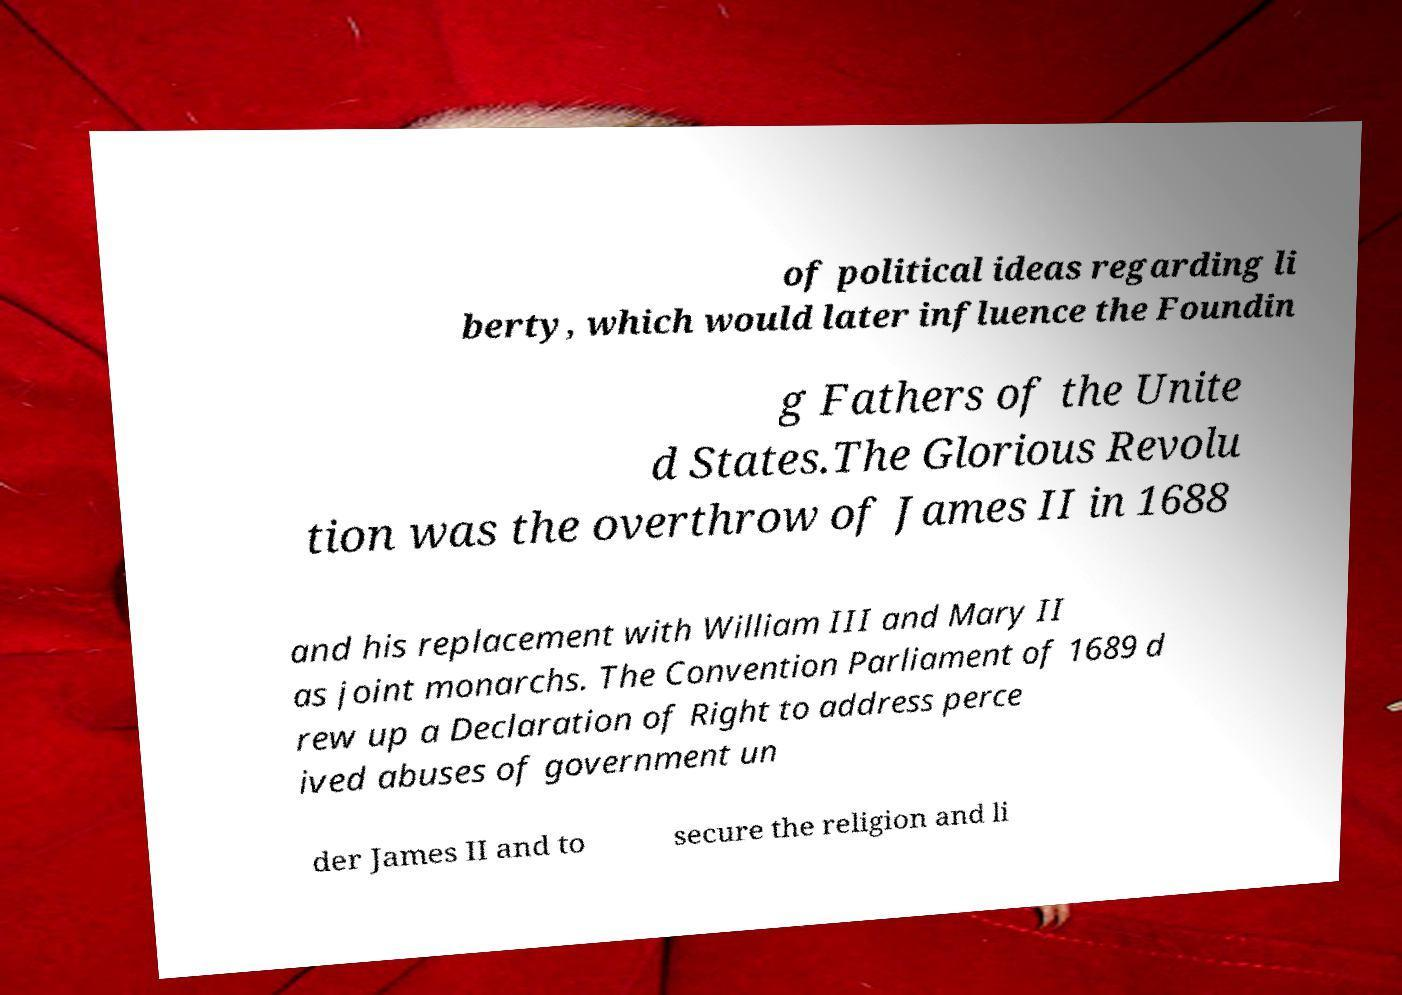For documentation purposes, I need the text within this image transcribed. Could you provide that? of political ideas regarding li berty, which would later influence the Foundin g Fathers of the Unite d States.The Glorious Revolu tion was the overthrow of James II in 1688 and his replacement with William III and Mary II as joint monarchs. The Convention Parliament of 1689 d rew up a Declaration of Right to address perce ived abuses of government un der James II and to secure the religion and li 